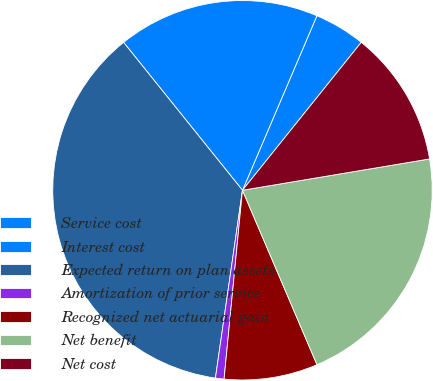Convert chart to OTSL. <chart><loc_0><loc_0><loc_500><loc_500><pie_chart><fcel>Service cost<fcel>Interest cost<fcel>Expected return on plan assets<fcel>Amortization of prior service<fcel>Recognized net actuarial gain<fcel>Net benefit<fcel>Net cost<nl><fcel>4.35%<fcel>17.19%<fcel>36.94%<fcel>0.73%<fcel>7.97%<fcel>21.21%<fcel>11.59%<nl></chart> 